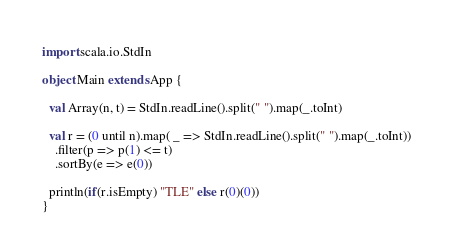<code> <loc_0><loc_0><loc_500><loc_500><_Scala_>import scala.io.StdIn

object Main extends App {
  
  val Array(n, t) = StdIn.readLine().split(" ").map(_.toInt)
  
  val r = (0 until n).map( _ => StdIn.readLine().split(" ").map(_.toInt))
    .filter(p => p(1) <= t)
    .sortBy(e => e(0))
 
  println(if(r.isEmpty) "TLE" else r(0)(0))
}
</code> 